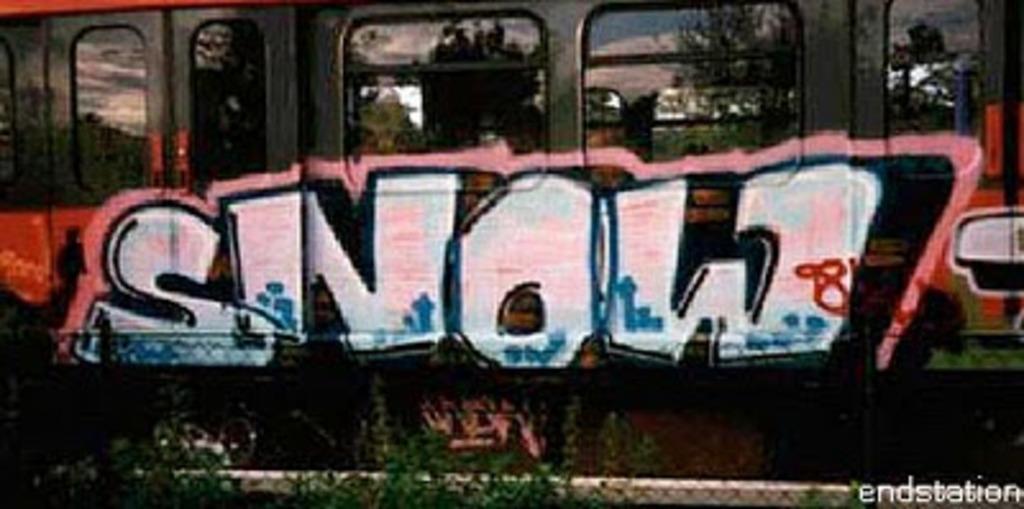Where is that spraypainted at?
Your response must be concise. Endstation. What word is spray painted on the train?
Ensure brevity in your answer.  Snow. 